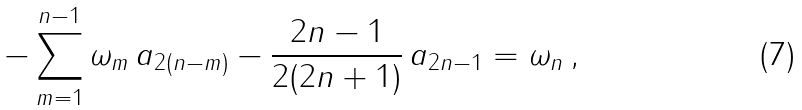<formula> <loc_0><loc_0><loc_500><loc_500>- \sum _ { m = 1 } ^ { n - 1 } \omega _ { m } \, a _ { 2 ( n - m ) } - \frac { 2 n - 1 } { 2 ( 2 n + 1 ) } \, a _ { 2 n - 1 } = \omega _ { n } \, ,</formula> 